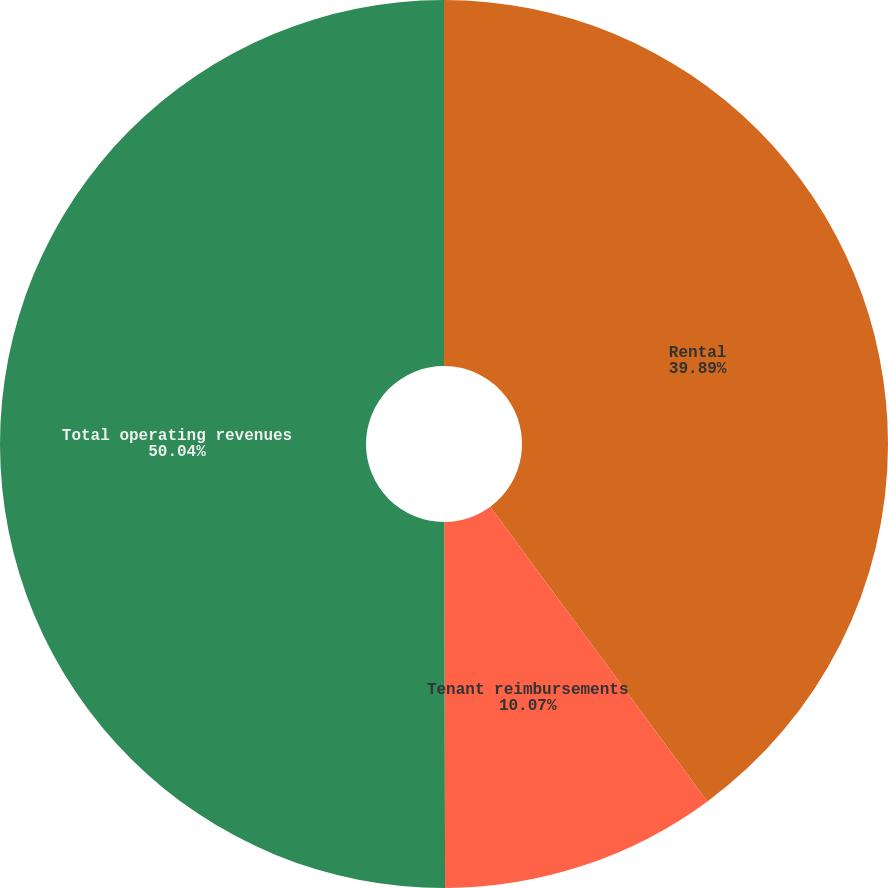Convert chart. <chart><loc_0><loc_0><loc_500><loc_500><pie_chart><fcel>Rental<fcel>Tenant reimbursements<fcel>Total operating revenues<nl><fcel>39.89%<fcel>10.07%<fcel>50.04%<nl></chart> 